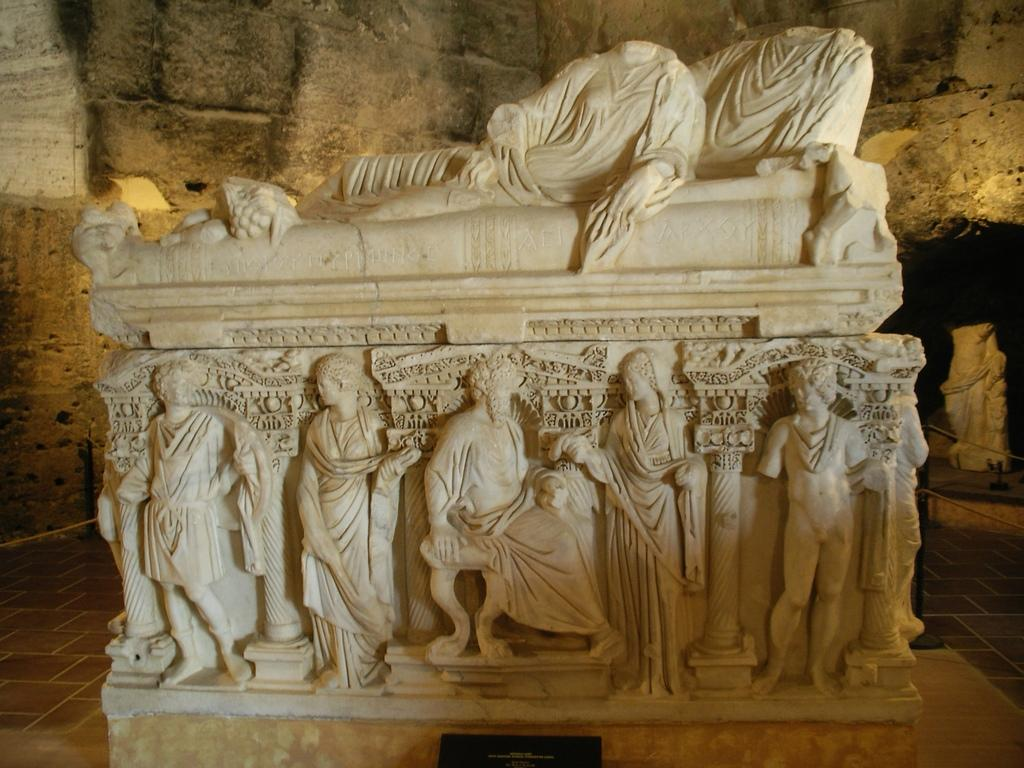What is the main subject in the image? There is a statue in the image. What is the color of the statue? The statue is white in color. Are there any people interacting with the statue? Yes, there are people on the statue. What can be seen in the background of the image? There is a wall visible in the background of the image. How many stars can be seen on the statue in the image? There are no stars visible on the statue in the image. What type of building is located behind the wall in the image? The provided facts do not mention any building behind the wall in the image. 